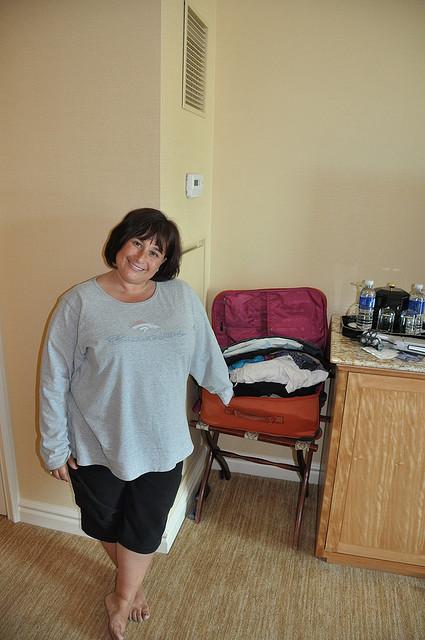What color is the water bottle?
Short answer required. Clear. What color is the wall?
Quick response, please. Beige. What do you call her hairstyle?
Concise answer only. Bob. Is this room disorganized?
Keep it brief. No. Is the woman's shirt long sleeved?
Quick response, please. Yes. Does the girl dye her hair?
Be succinct. No. What kind of cloth is the poodle standing on?
Be succinct. No poodle. How many bars on the chair are there?
Quick response, please. 2. What pattern is on the rug?
Write a very short answer. No rug. What color is the boy's vest?
Answer briefly. None. Is this a female?
Be succinct. Yes. How does the women in this picture feel?
Write a very short answer. Happy. Is there a lot of stuff on the table?
Write a very short answer. Yes. What is she looking at?
Write a very short answer. Camera. 